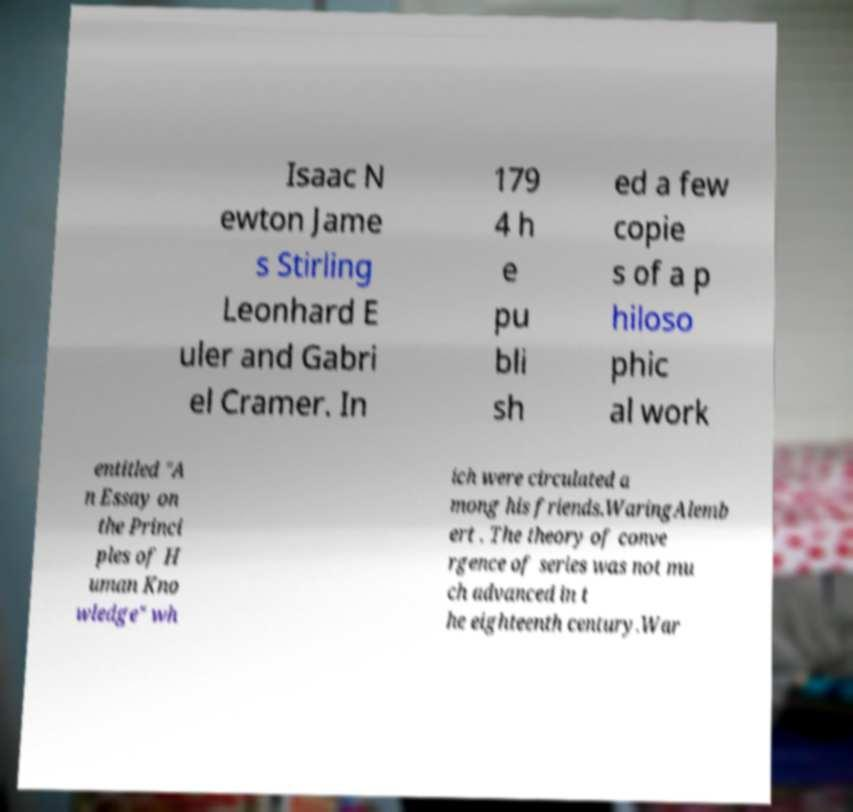Could you assist in decoding the text presented in this image and type it out clearly? Isaac N ewton Jame s Stirling Leonhard E uler and Gabri el Cramer. In 179 4 h e pu bli sh ed a few copie s of a p hiloso phic al work entitled "A n Essay on the Princi ples of H uman Kno wledge" wh ich were circulated a mong his friends.WaringAlemb ert . The theory of conve rgence of series was not mu ch advanced in t he eighteenth century.War 